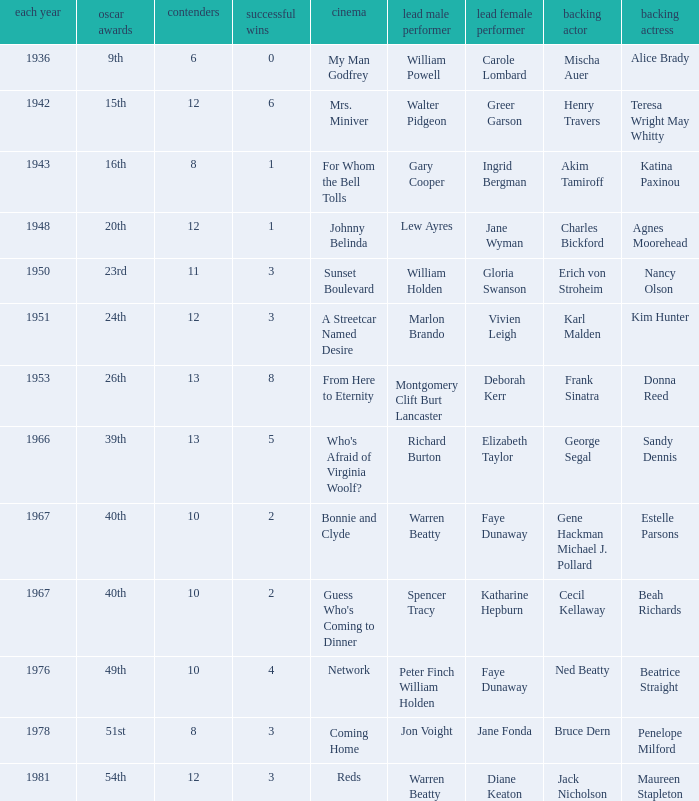Who was the supporting actress in a film with Diane Keaton as the leading actress? Maureen Stapleton. 